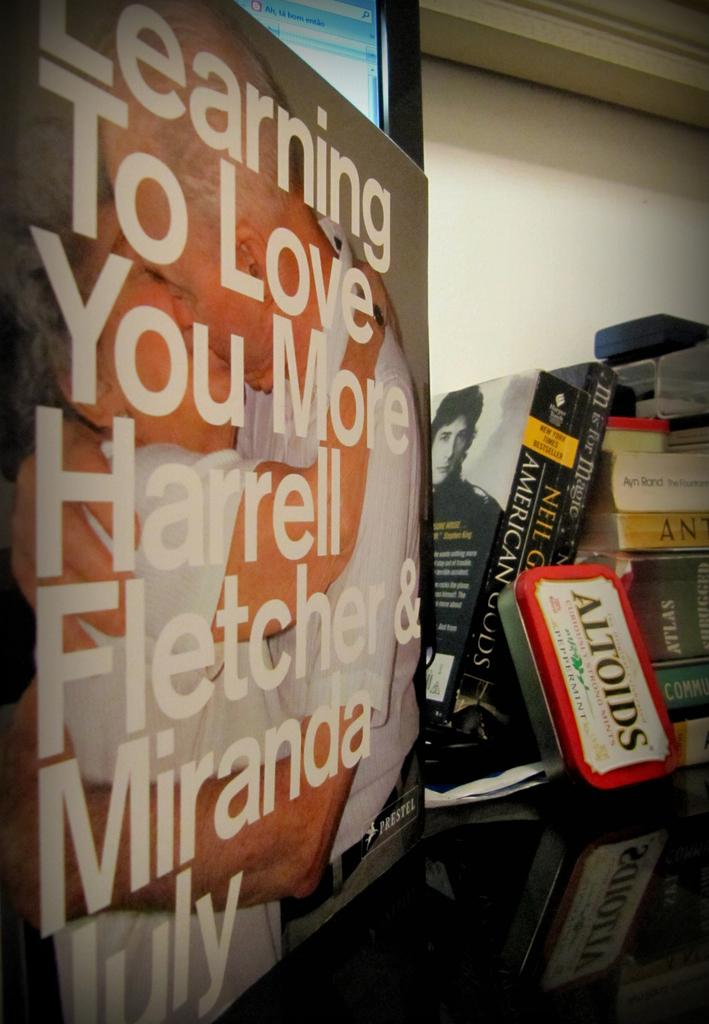<image>
Offer a succinct explanation of the picture presented. A poster that says Learning To Love is by a stack of books and Altoids. 